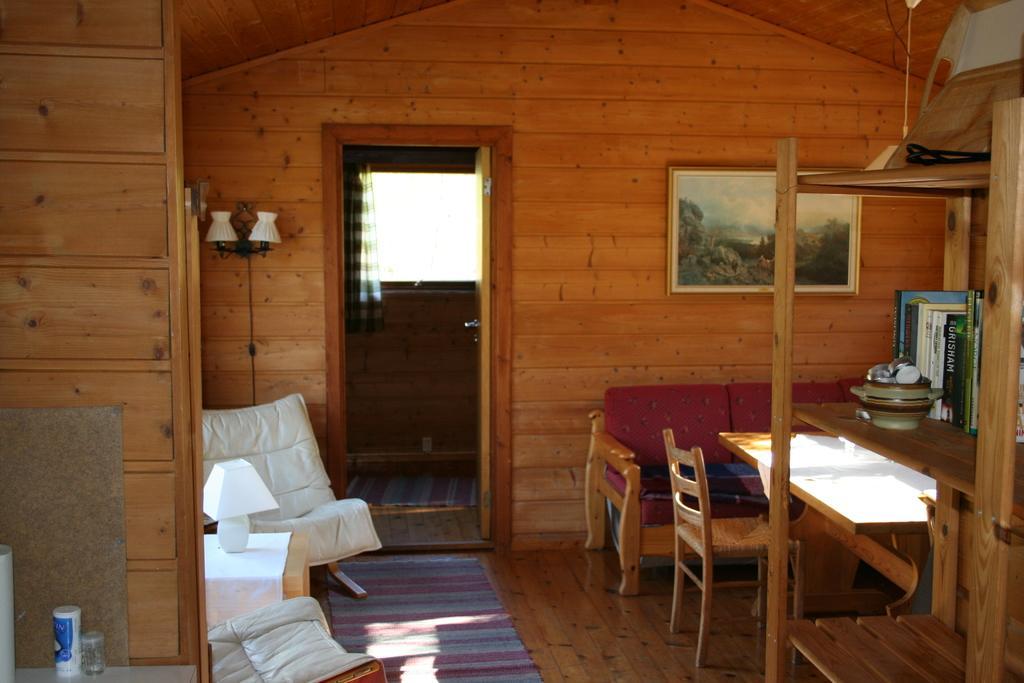Describe this image in one or two sentences. In this image we can see inside view of the house which includes window and curtain, on the right we can see sofa, table and chairs, after that we can see wooden shelf unit and some objects on it, on the left we can see table and lamp on it, near that we can see some objects, we can see the floor and floor mat. 